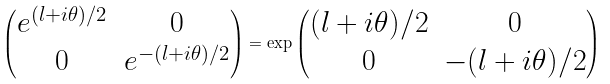Convert formula to latex. <formula><loc_0><loc_0><loc_500><loc_500>\begin{pmatrix} e ^ { ( l + i \theta ) / 2 } & 0 \\ 0 & e ^ { - ( l + i \theta ) / 2 } \end{pmatrix} = \exp \begin{pmatrix} ( l + i \theta ) / 2 & 0 \\ 0 & { - ( l + i \theta ) / 2 } \end{pmatrix}</formula> 